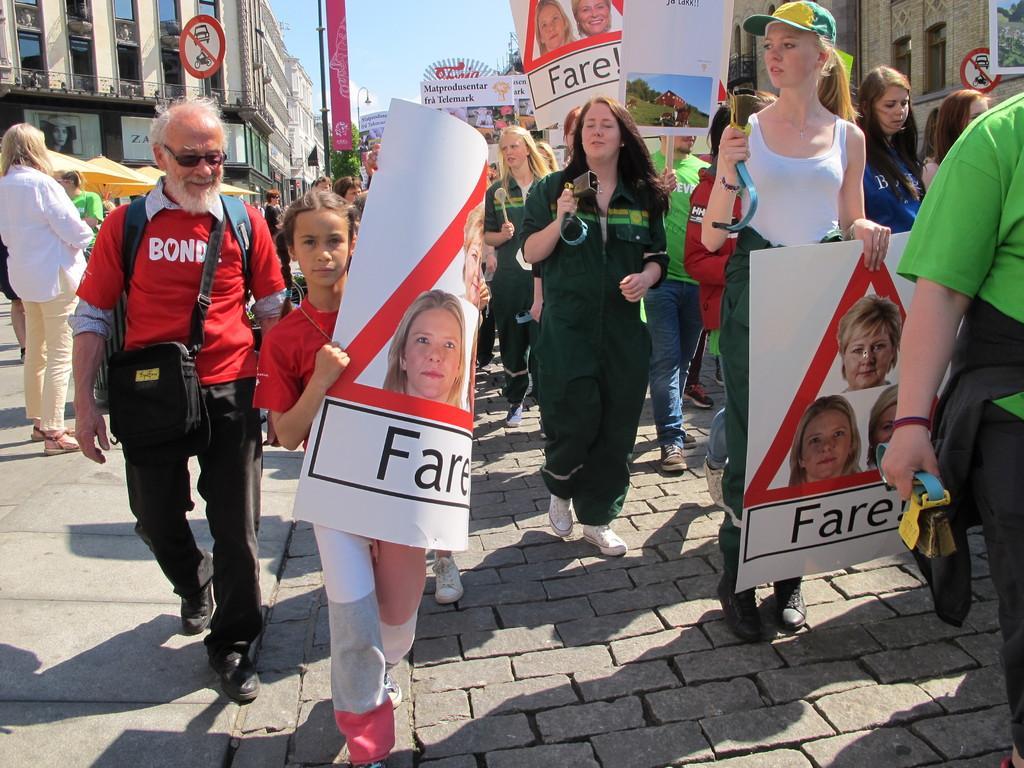In one or two sentences, can you explain what this image depicts? In this image we can see a group of people standing on the ground. One person is wearing a red t shirt and spectacles is carrying a bag. One girl is holding a card in her hand. In the background, we can see some sign boards with some text, a group of buildings and the sky. 